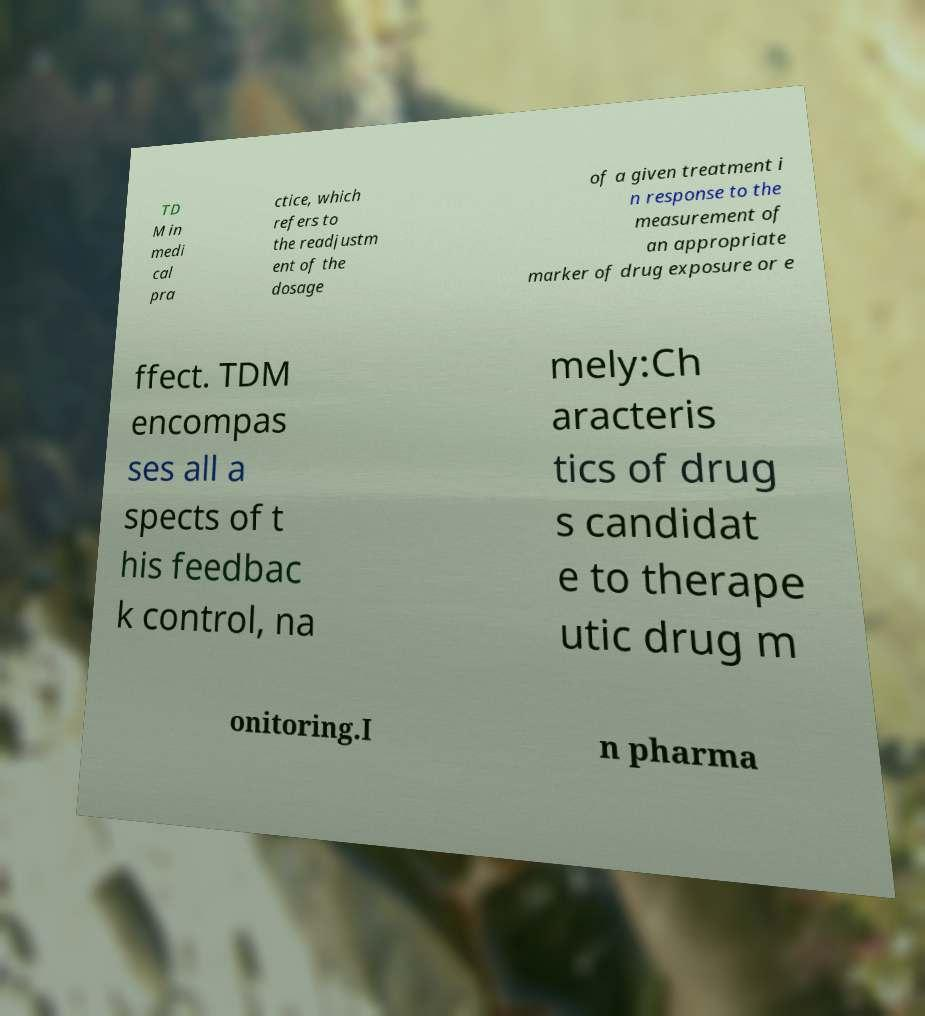Can you read and provide the text displayed in the image?This photo seems to have some interesting text. Can you extract and type it out for me? TD M in medi cal pra ctice, which refers to the readjustm ent of the dosage of a given treatment i n response to the measurement of an appropriate marker of drug exposure or e ffect. TDM encompas ses all a spects of t his feedbac k control, na mely:Ch aracteris tics of drug s candidat e to therape utic drug m onitoring.I n pharma 